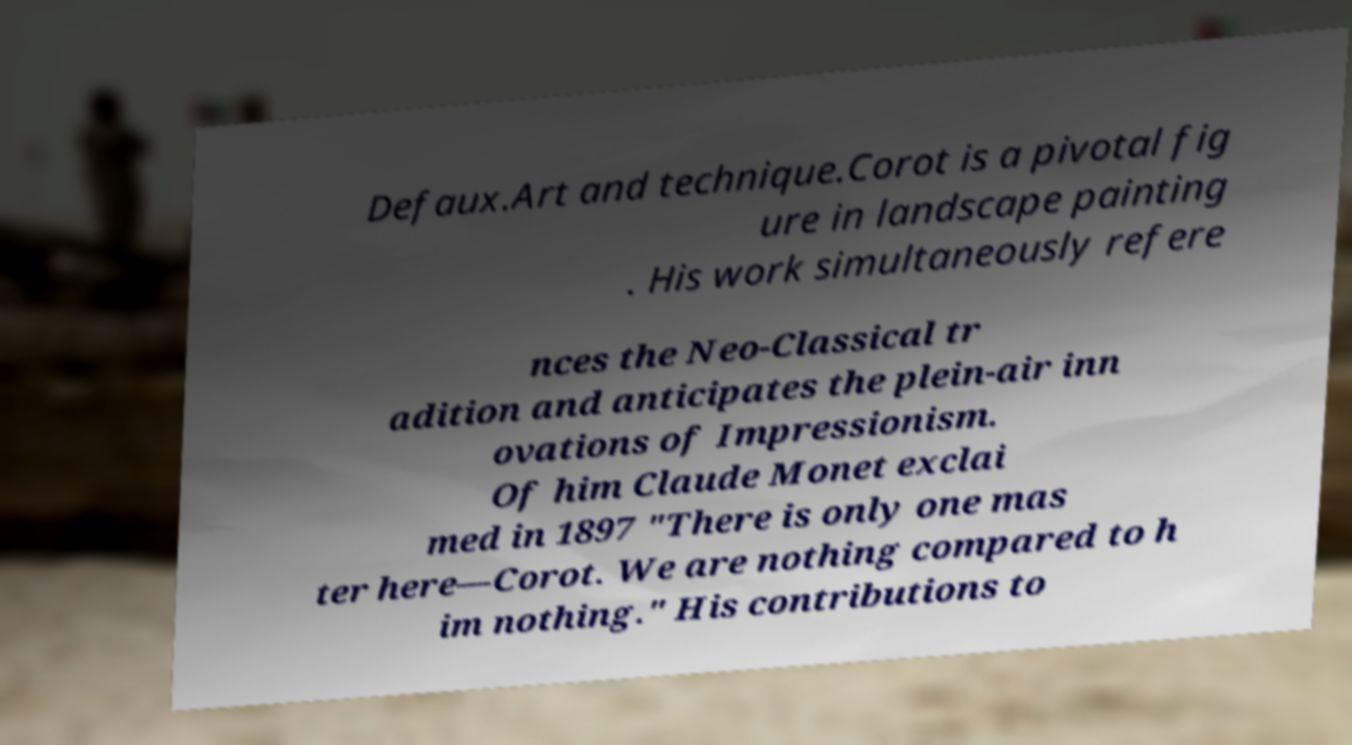Could you extract and type out the text from this image? Defaux.Art and technique.Corot is a pivotal fig ure in landscape painting . His work simultaneously refere nces the Neo-Classical tr adition and anticipates the plein-air inn ovations of Impressionism. Of him Claude Monet exclai med in 1897 "There is only one mas ter here—Corot. We are nothing compared to h im nothing." His contributions to 